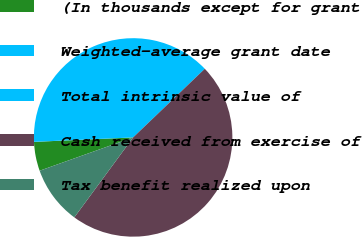Convert chart to OTSL. <chart><loc_0><loc_0><loc_500><loc_500><pie_chart><fcel>(In thousands except for grant<fcel>Weighted-average grant date<fcel>Total intrinsic value of<fcel>Cash received from exercise of<fcel>Tax benefit realized upon<nl><fcel>4.73%<fcel>0.01%<fcel>38.55%<fcel>47.25%<fcel>9.46%<nl></chart> 